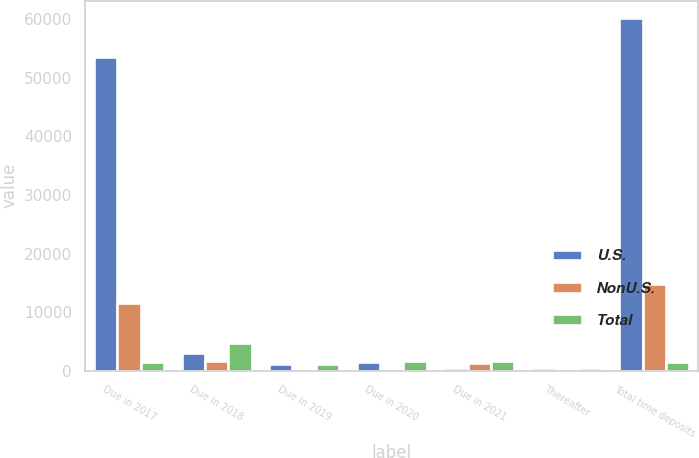<chart> <loc_0><loc_0><loc_500><loc_500><stacked_bar_chart><ecel><fcel>Due in 2017<fcel>Due in 2018<fcel>Due in 2019<fcel>Due in 2020<fcel>Due in 2021<fcel>Thereafter<fcel>Total time deposits<nl><fcel>U.S.<fcel>53584<fcel>3081<fcel>1131<fcel>1475<fcel>406<fcel>483<fcel>60160<nl><fcel>NonU.S.<fcel>11528<fcel>1702<fcel>47<fcel>250<fcel>1238<fcel>19<fcel>14784<nl><fcel>Total<fcel>1475<fcel>4783<fcel>1178<fcel>1725<fcel>1644<fcel>502<fcel>1475<nl></chart> 